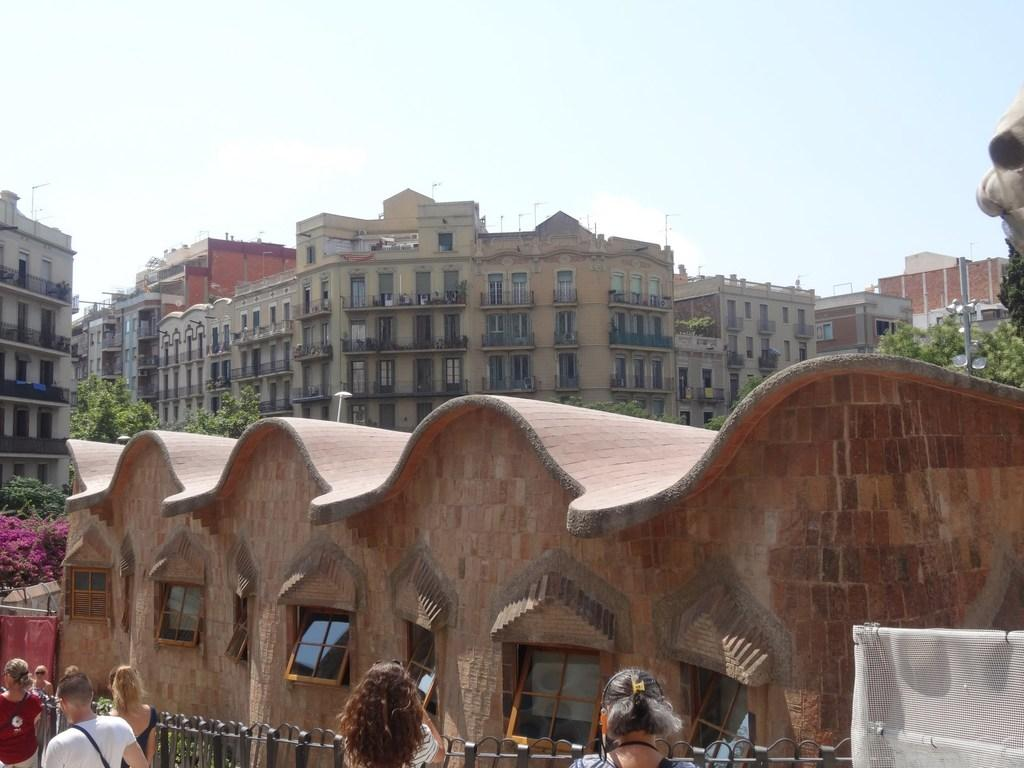What type of structures are visible in the image? There are buildings in the image. What architectural features can be seen on the buildings? The buildings have walls with arches and windows. What type of barrier is present in the image? There is a fence in the image. Who or what can be seen in the image besides the buildings and fence? There are people and trees present in the image. What is visible in the background of the image? The sky is visible in the image. What type of shock can be seen affecting the toad in the image? There is no toad present in the image, and therefore no shock can be observed. How many pins are visible in the image? There are no pins visible in the image. 